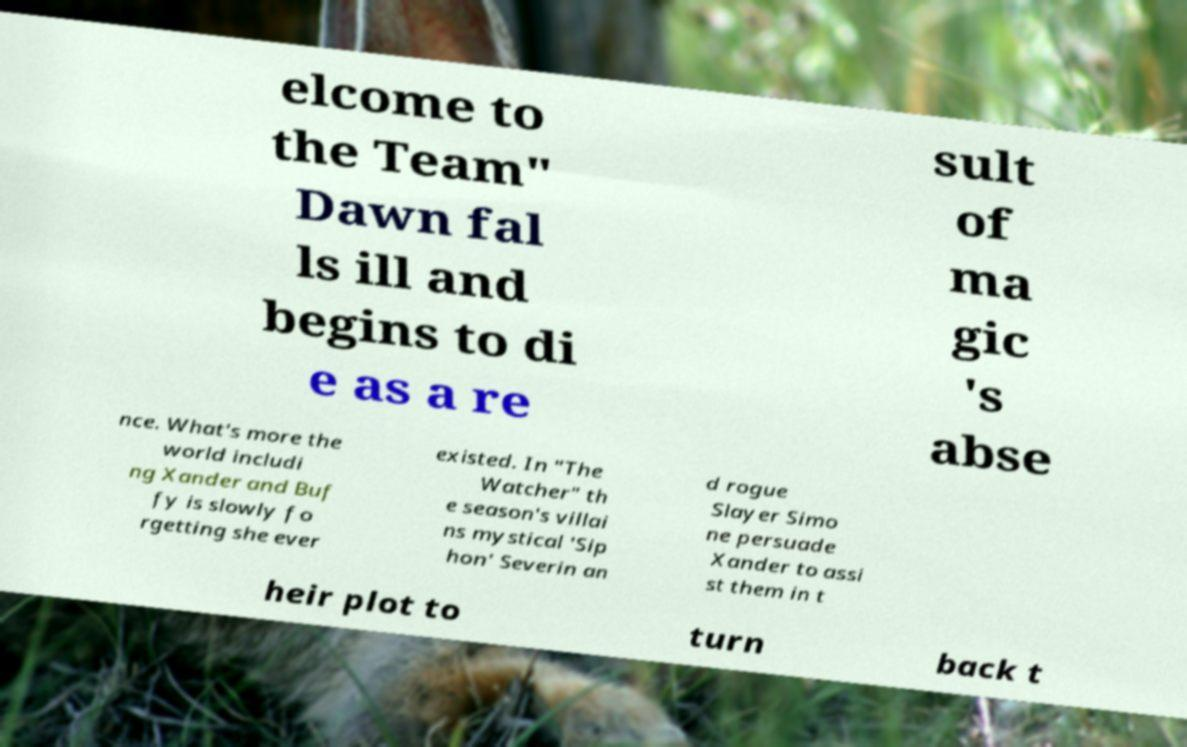I need the written content from this picture converted into text. Can you do that? elcome to the Team" Dawn fal ls ill and begins to di e as a re sult of ma gic 's abse nce. What's more the world includi ng Xander and Buf fy is slowly fo rgetting she ever existed. In "The Watcher" th e season's villai ns mystical 'Sip hon' Severin an d rogue Slayer Simo ne persuade Xander to assi st them in t heir plot to turn back t 